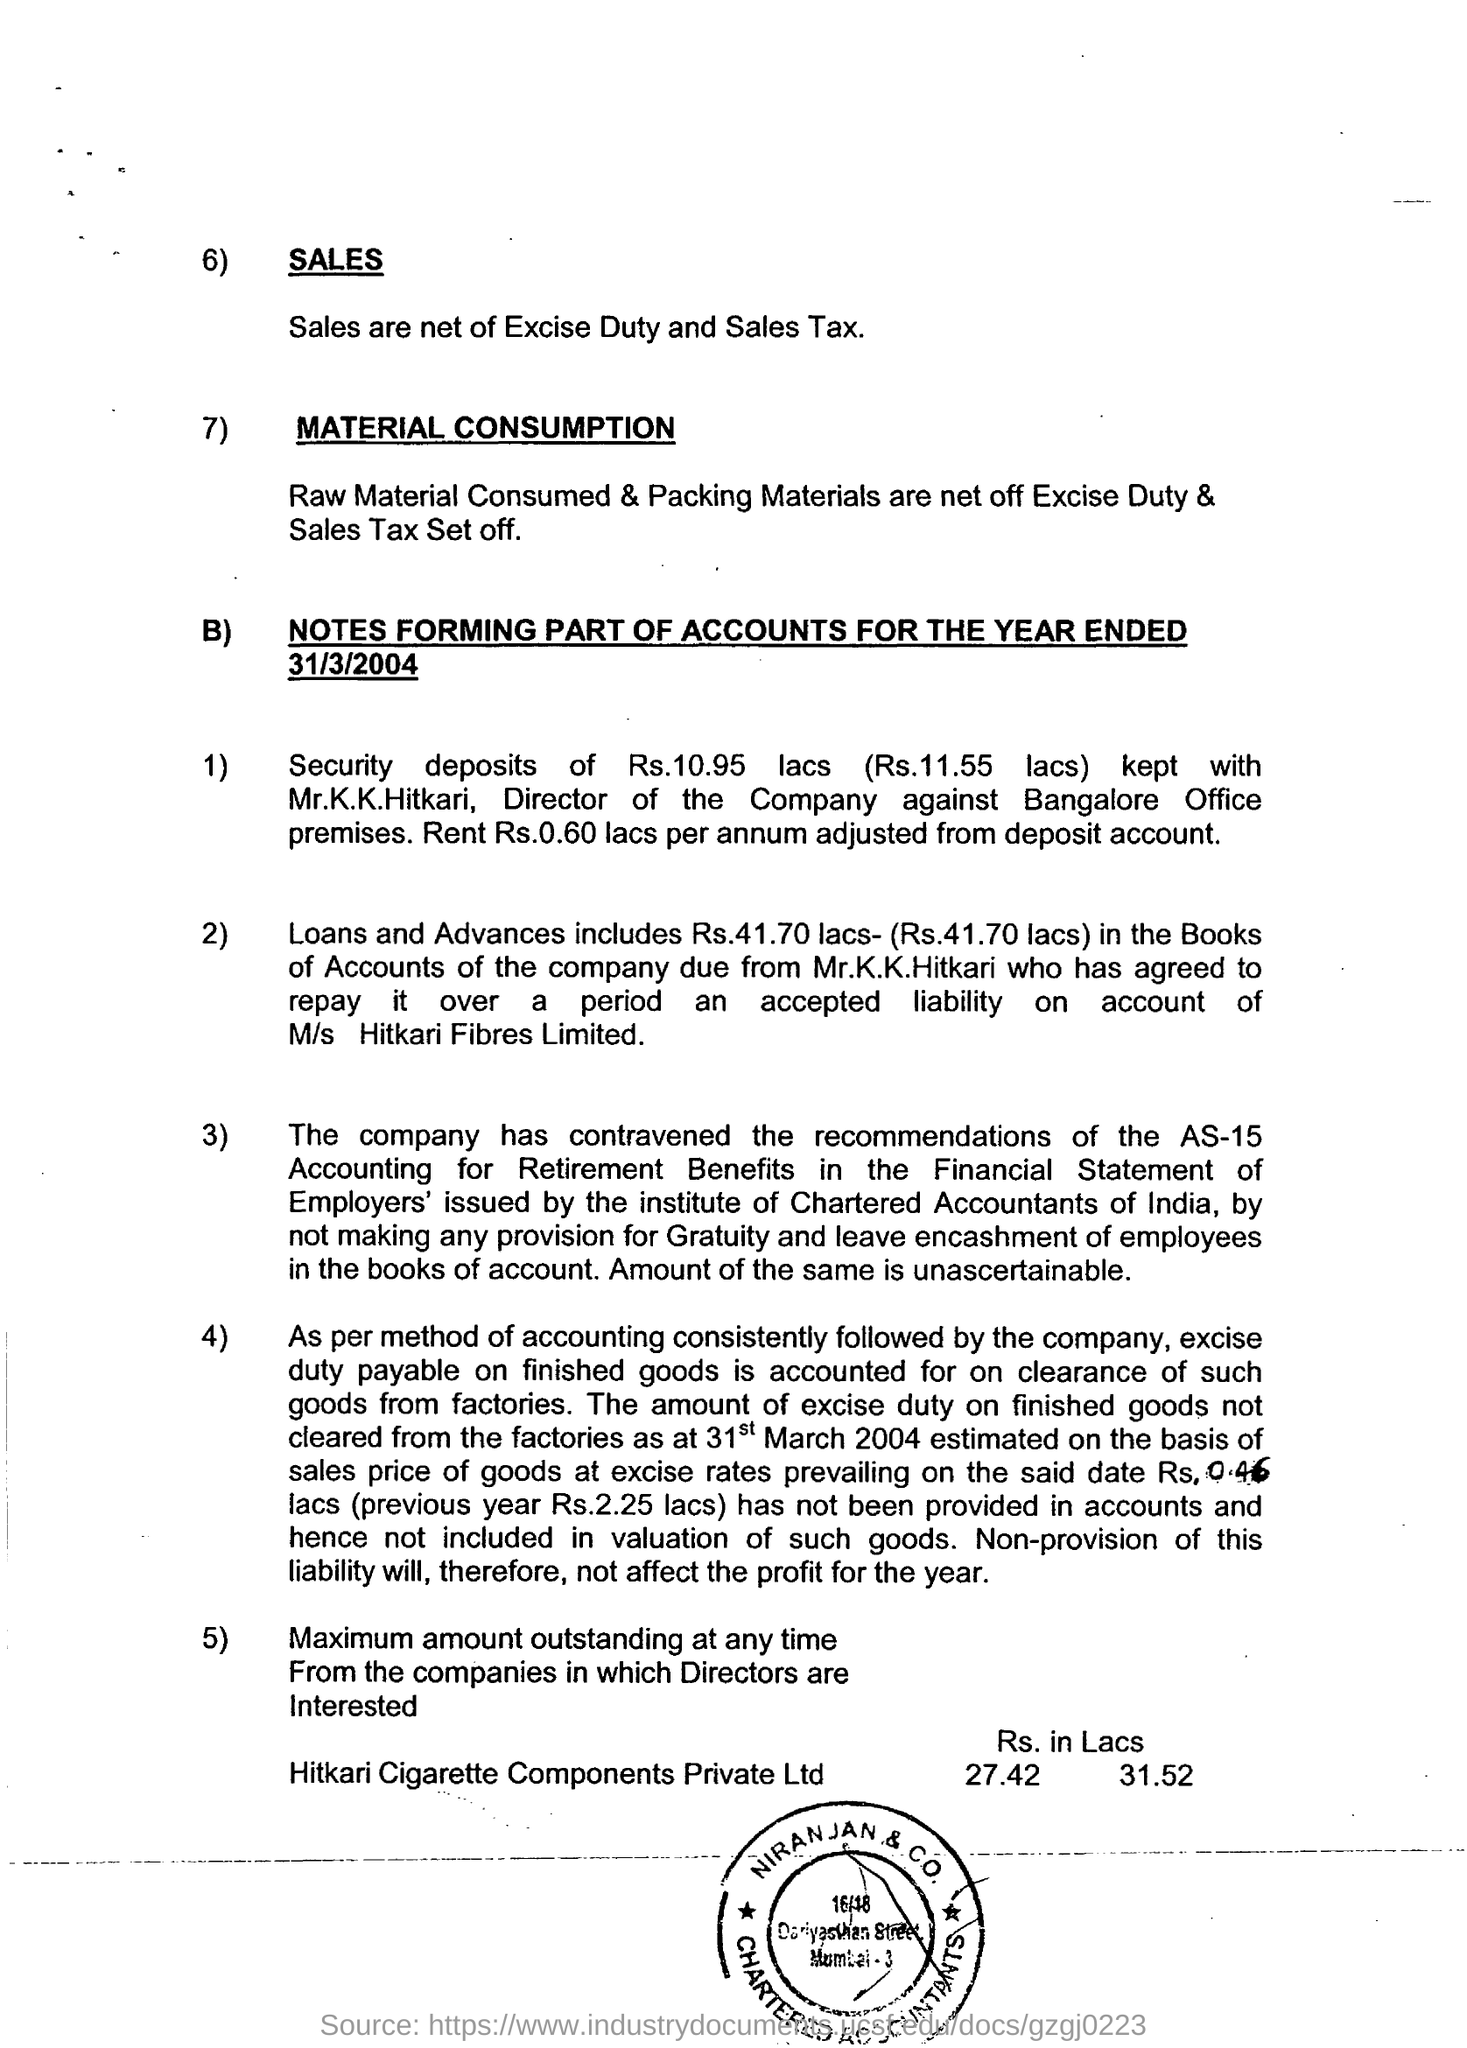The company has contravened the recommendations of the AS 15 accounting for what benefits?
Provide a succinct answer. Retirement Benefits. 